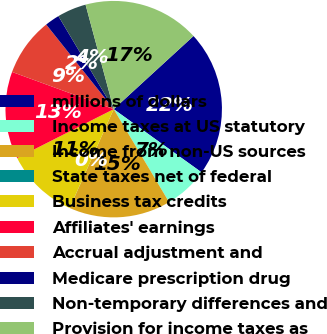<chart> <loc_0><loc_0><loc_500><loc_500><pie_chart><fcel>millions of dollars<fcel>Income taxes at US statutory<fcel>Income from non-US sources<fcel>State taxes net of federal<fcel>Business tax credits<fcel>Affiliates' earnings<fcel>Accrual adjustment and<fcel>Medicare prescription drug<fcel>Non-temporary differences and<fcel>Provision for income taxes as<nl><fcel>21.73%<fcel>6.53%<fcel>15.21%<fcel>0.01%<fcel>10.87%<fcel>13.04%<fcel>8.7%<fcel>2.18%<fcel>4.35%<fcel>17.38%<nl></chart> 